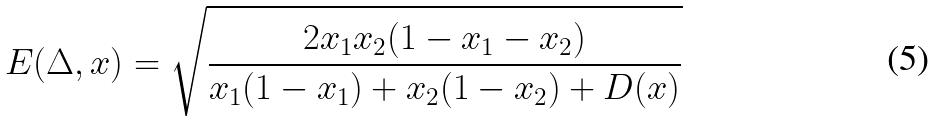<formula> <loc_0><loc_0><loc_500><loc_500>E ( \Delta , x ) = \sqrt { \frac { 2 x _ { 1 } x _ { 2 } ( 1 - x _ { 1 } - x _ { 2 } ) } { x _ { 1 } ( 1 - x _ { 1 } ) + x _ { 2 } ( 1 - x _ { 2 } ) + D ( x ) } }</formula> 